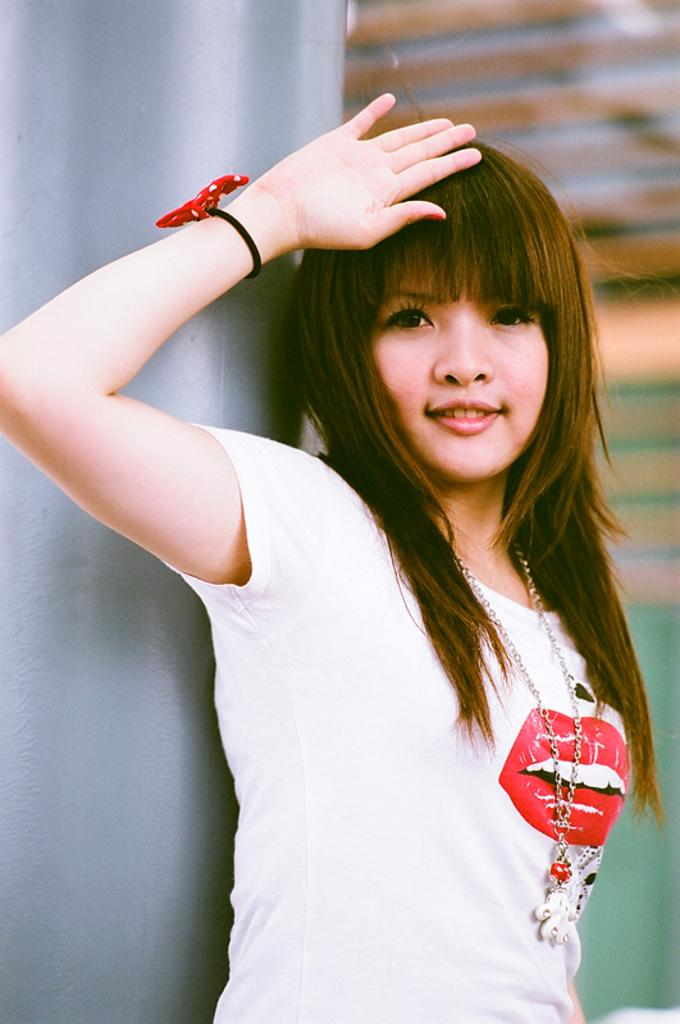Who is the main subject in the image? There is a girl in the image. What is the girl wearing on her upper body? The girl is wearing a white color T-shirt. Are there any accessories visible on the girl? Yes, the girl is wearing jewelry. What can be seen on the left side of the image? There is a pillar on the left side of the image. What is visible in the background of the image? There appears to be a wall in the background of the image. How does the girl wave to the crowd in the image? There is no crowd present in the image, and the girl is not waving. 